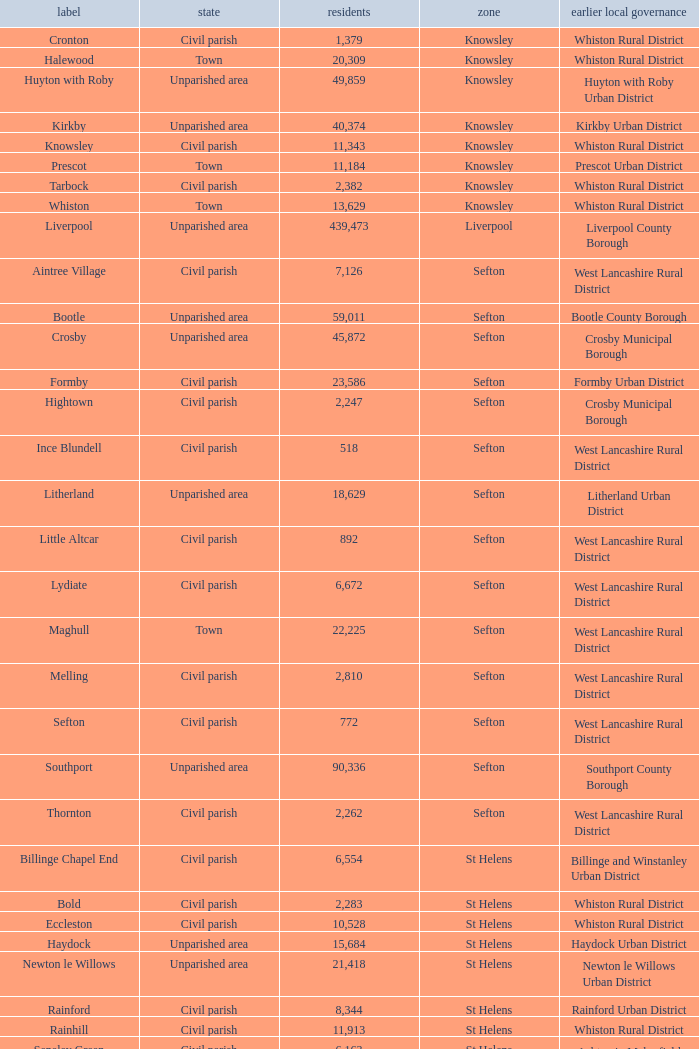What is the district of wallasey Wirral. 